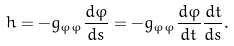<formula> <loc_0><loc_0><loc_500><loc_500>h = - g _ { \varphi \varphi } \frac { d \varphi } { d s } = - g _ { \varphi \varphi } \frac { d \varphi } { d t } \frac { d t } { d s } .</formula> 